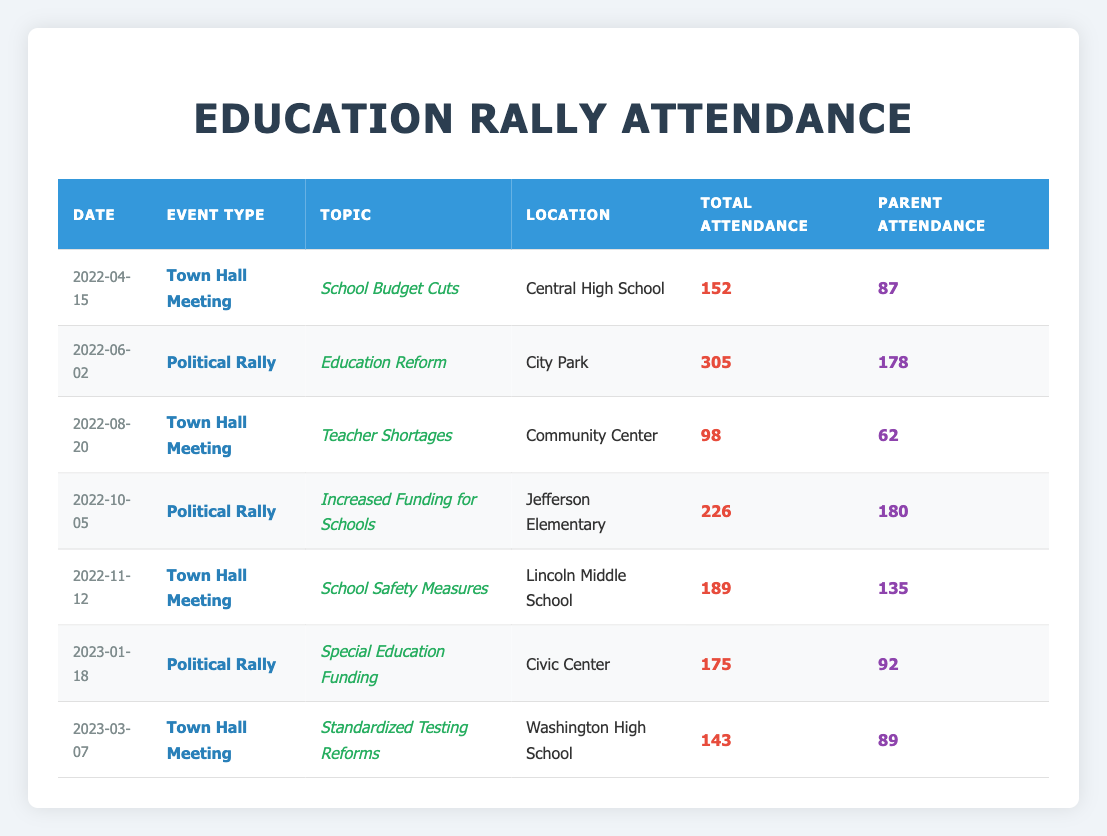What was the highest attendance at a political rally or town hall meeting? Checking the table, the highest attendance is found by comparing all attendance figures. The highest value is 305 at the political rally on June 2, 2022.
Answer: 305 How many parents attended the Town Hall Meeting on School Safety Measures? For the Town Hall Meeting on School Safety Measures held on November 12, 2022, the table indicates that 135 parents attended.
Answer: 135 What is the average attendance of parents across all events listed? To find the average, we sum the parent attendance across all events: 87 + 178 + 62 + 180 + 135 + 92 + 89 = 823. There are 7 events, so the average is 823/7 = 117.57, rounded to 118.
Answer: 118 Did any event have more than 150 attendees from parents? We examine the parent attendance for each event: 87, 178, 62, 180, 135, 92, and 89. Since both the political rally on June 2, 2022, and the political rally on October 5, 2022, had more than 150 parents in attendance, the answer is yes.
Answer: Yes Which topic had the lowest total attendance and what was it? We review the total attendance for all events: 152, 305, 98, 226, 189, 175, and 143. The lowest is 98 at the Town Hall Meeting on Teacher Shortages on August 20, 2022.
Answer: Teacher Shortages What was the difference in total attendance between the event with the highest and lowest attendance? The highest attendance is 305 (June 2, 2022) and the lowest is 98 (August 20, 2022). The difference is calculated as 305 - 98 = 207.
Answer: 207 What was the total number of attendees across all Town Hall Meetings? We check the attendance from the Town Hall Meetings: 152 (April 15), 98 (August 20), 189 (November 12), and 143 (March 7). Summing those gives us 152 + 98 + 189 + 143 = 582.
Answer: 582 On which date was the Town Hall Meeting on Standardized Testing Reforms held? Looking at the table, the Town Hall Meeting on Standardized Testing Reforms took place on March 7, 2023.
Answer: March 7, 2023 How many more parents attended the event on Education Reform compared to the event on Standardized Testing Reforms? For the Education Reform political rally on June 2, 2022, parent attendance was 178, while for Standardized Testing Reforms on March 7, 2023, it was 89. The difference is 178 - 89 = 89.
Answer: 89 